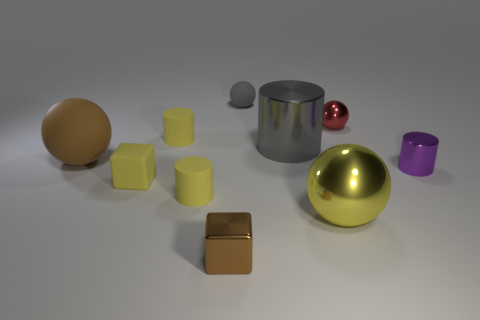Subtract all small shiny spheres. How many spheres are left? 3 Subtract all blue spheres. How many yellow cylinders are left? 2 Subtract 2 cylinders. How many cylinders are left? 2 Subtract all brown spheres. How many spheres are left? 3 Subtract all cylinders. How many objects are left? 6 Subtract 0 cyan cylinders. How many objects are left? 10 Subtract all green cylinders. Subtract all green balls. How many cylinders are left? 4 Subtract all yellow blocks. Subtract all large yellow objects. How many objects are left? 8 Add 3 big brown matte things. How many big brown matte things are left? 4 Add 4 big gray metal cylinders. How many big gray metal cylinders exist? 5 